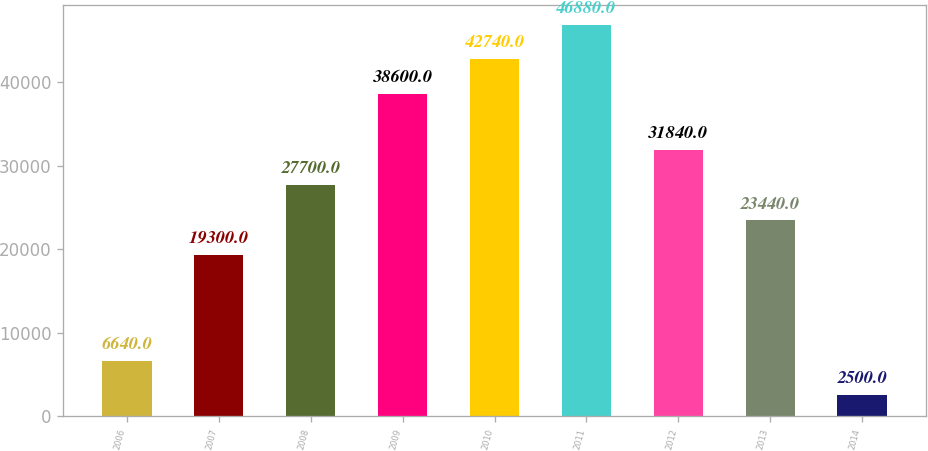Convert chart to OTSL. <chart><loc_0><loc_0><loc_500><loc_500><bar_chart><fcel>2006<fcel>2007<fcel>2008<fcel>2009<fcel>2010<fcel>2011<fcel>2012<fcel>2013<fcel>2014<nl><fcel>6640<fcel>19300<fcel>27700<fcel>38600<fcel>42740<fcel>46880<fcel>31840<fcel>23440<fcel>2500<nl></chart> 